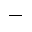Convert formula to latex. <formula><loc_0><loc_0><loc_500><loc_500>-</formula> 